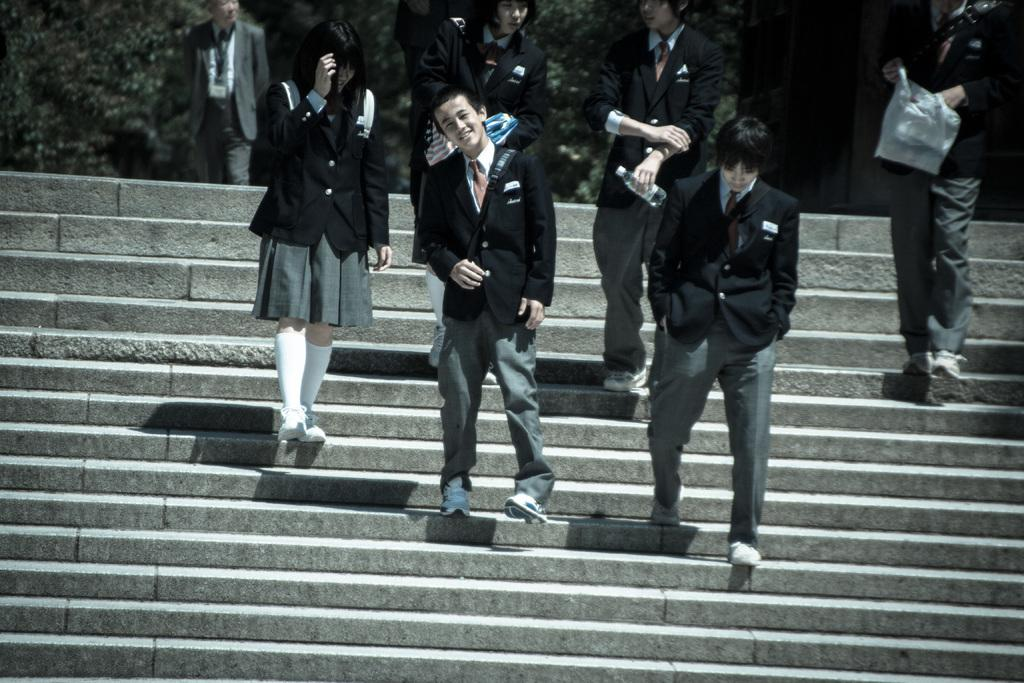What is happening in the image? There is a group of people in the image, and they are on a staircase. What can be seen in the background of the image? There are trees visible in the background of the image. Is there any activity happening in the background? Yes, there is a person walking in the background of the image. What type of game is being played by the people on the staircase? There is no game being played in the image; the people are simply standing on the staircase. 